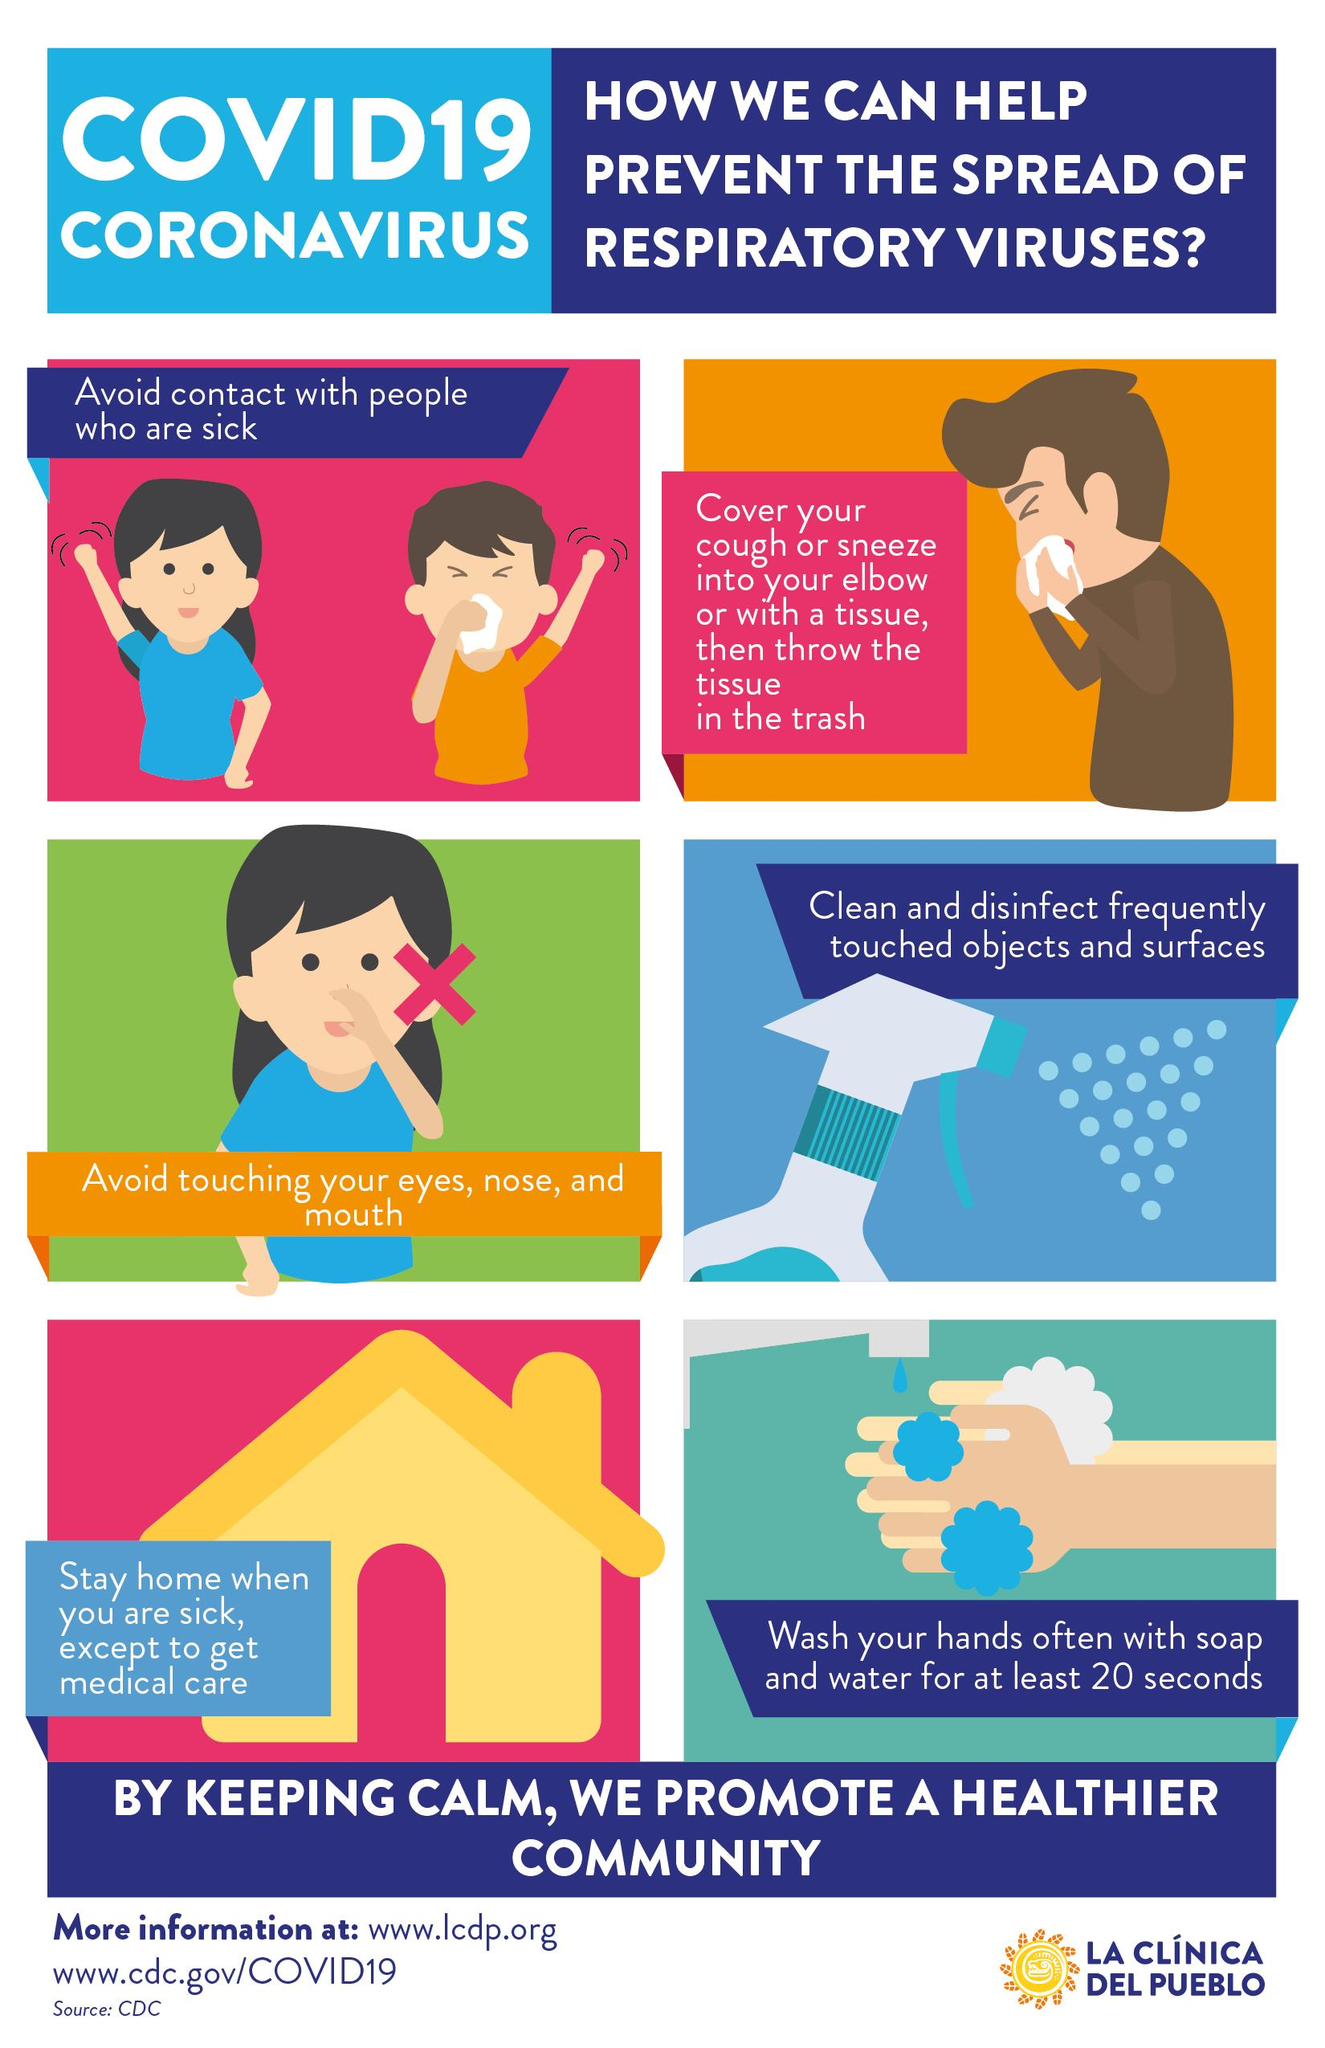Mention a couple of crucial points in this snapshot. It is recommended to wash one's hands for at least 20 seconds in order to effectively prevent the spread of COVID-19. 